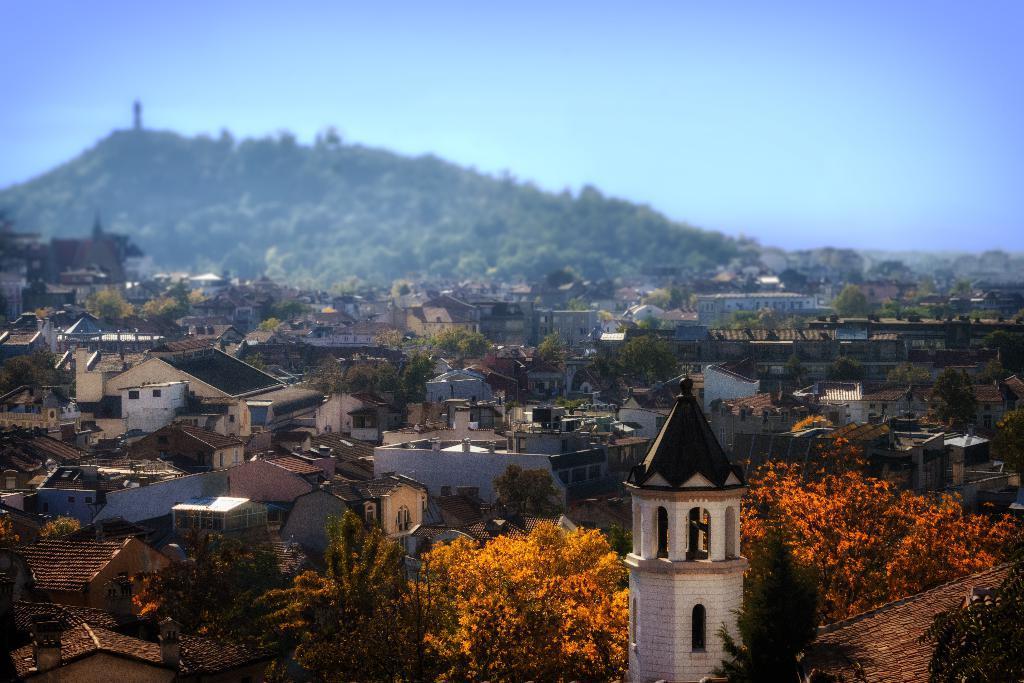Please provide a concise description of this image. In this image there are some trees and buildings as we can see in the bottom of this image. There is a mountain in the background. There is sky on the top of this image. 